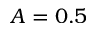<formula> <loc_0><loc_0><loc_500><loc_500>A = 0 . 5</formula> 